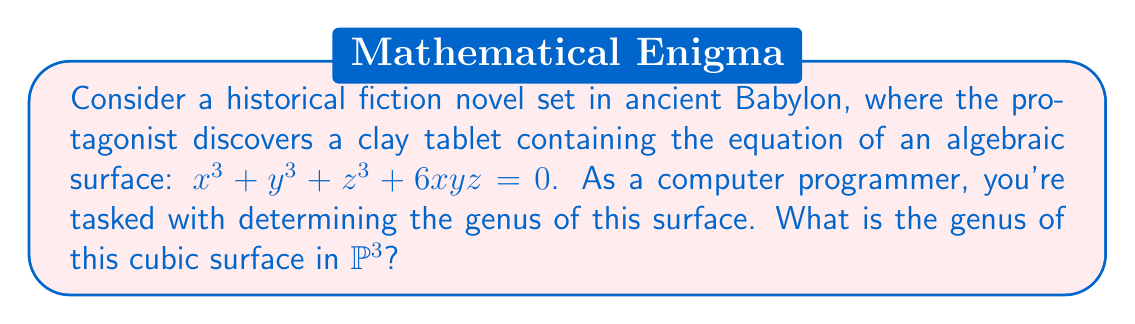Teach me how to tackle this problem. To determine the genus of this algebraic surface, we'll follow these steps:

1) First, we recognize that this is a smooth cubic surface in $\mathbb{P}^3$. The smoothness can be verified by checking that the partial derivatives don't simultaneously vanish at any point, but we'll assume this for brevity.

2) For a smooth surface $S$ of degree $d$ in $\mathbb{P}^3$, we can use the formula for the geometric genus:

   $$p_g(S) = \frac{(d-1)(d-2)(d-3)}{6}$$

3) In our case, $d = 3$ (cubic surface), so we calculate:

   $$p_g(S) = \frac{(3-1)(3-2)(3-3)}{6} = \frac{2 \cdot 1 \cdot 0}{6} = 0$$

4) For surfaces, the arithmetic genus $p_a$ is equal to the geometric genus $p_g$. Therefore, $p_a(S) = 0$.

5) The genus $g$ of a surface is defined as its arithmetic genus. Thus, $g = p_a(S) = 0$.

This result aligns with the well-known fact that all smooth cubic surfaces in $\mathbb{P}^3$ have genus 0.
Answer: $0$ 